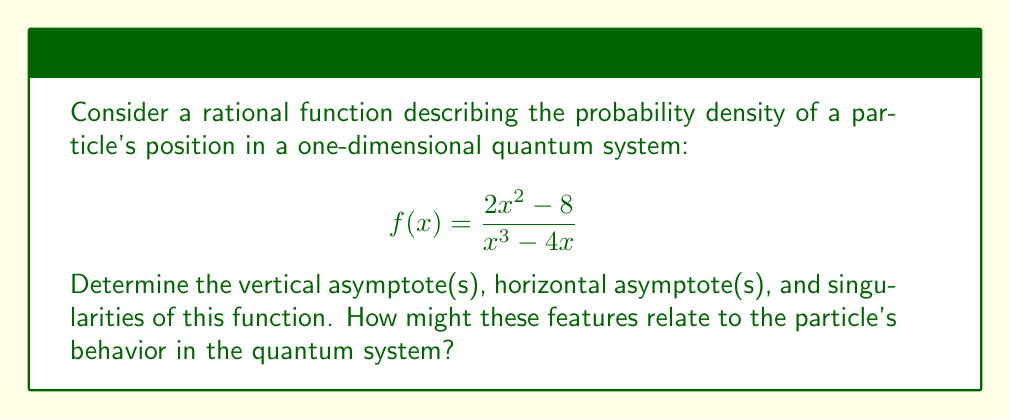Help me with this question. 1. Vertical asymptotes:
   Vertical asymptotes occur when the denominator equals zero.
   Solve $x^3 - 4x = 0$:
   $x(x^2 - 4) = 0$
   $x(x+2)(x-2) = 0$
   $x = 0, -2, 2$
   
   Vertical asymptotes are at $x = 0$ and $x = \pm 2$.

2. Horizontal asymptote:
   Compare the degrees of numerator and denominator:
   Degree of numerator = 2
   Degree of denominator = 3
   Since degree of denominator > degree of numerator, the horizontal asymptote is y = 0.

3. Singularities:
   Singularities occur at the same points as vertical asymptotes: $x = 0, \pm 2$.

4. To find the behavior near singularities, we can factor the numerator and denominator:
   $$f(x) = \frac{2(x^2 - 4)}{x(x^2 - 4)} = \frac{2}{x}$$
   The $(x^2 - 4)$ terms cancel out, revealing that the function approaches positive infinity as x approaches 0 from the right, and negative infinity as x approaches 0 from the left.

5. Quantum interpretation:
   - The vertical asymptotes at $x = \pm 2$ might represent boundaries of the particle's confinement.
   - The singularity at $x = 0$ could indicate a central point of high probability density.
   - The horizontal asymptote at y = 0 suggests that the probability density approaches zero as x approaches infinity, which is consistent with the normalization of wavefunctions in quantum mechanics.
Answer: Vertical asymptotes: $x = 0, \pm 2$
Horizontal asymptote: $y = 0$
Singularities: $x = 0, \pm 2$ 